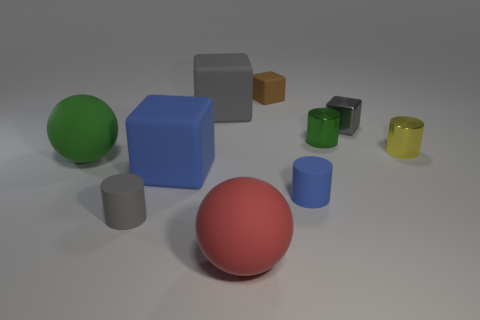There is a red matte thing that is the same size as the green sphere; what shape is it?
Provide a succinct answer. Sphere. There is a large thing that is the same color as the small metal cube; what is it made of?
Offer a terse response. Rubber. Are there any gray rubber things behind the small gray metal block?
Provide a succinct answer. Yes. Is there another large metal thing that has the same shape as the large green thing?
Offer a terse response. No. Is the shape of the green object that is in front of the tiny yellow object the same as the big thing that is in front of the big blue cube?
Provide a succinct answer. Yes. Is there another metallic cylinder that has the same size as the gray cylinder?
Your answer should be compact. Yes. Is the number of gray cylinders right of the large blue cube the same as the number of tiny brown rubber objects that are in front of the yellow cylinder?
Your response must be concise. Yes. Are the tiny gray thing to the left of the small green metallic thing and the small cylinder right of the green metallic thing made of the same material?
Offer a very short reply. No. What is the big blue object made of?
Give a very brief answer. Rubber. What number of other things are there of the same color as the tiny metal block?
Ensure brevity in your answer.  2. 